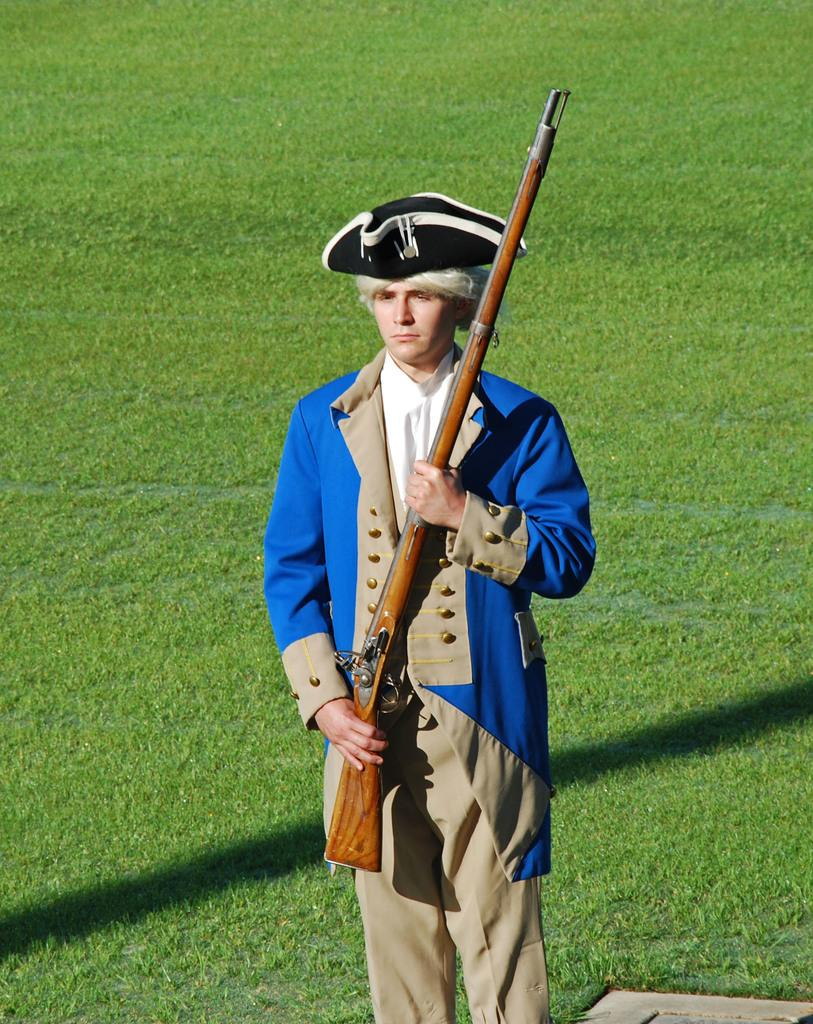Who is present in the image? There is a man in the image. What is the man doing in the image? The man is standing in the image. What is the man wearing in the image? The man is wearing clothes and a hat in the image. What is the man holding in the image? The man is holding a rifle in his hands in the image. What type of environment is visible in the image? There is grass visible in the image. What type of legal advice is the man providing to the deer in the image? There is no deer present in the image, and the man is not providing any legal advice. 